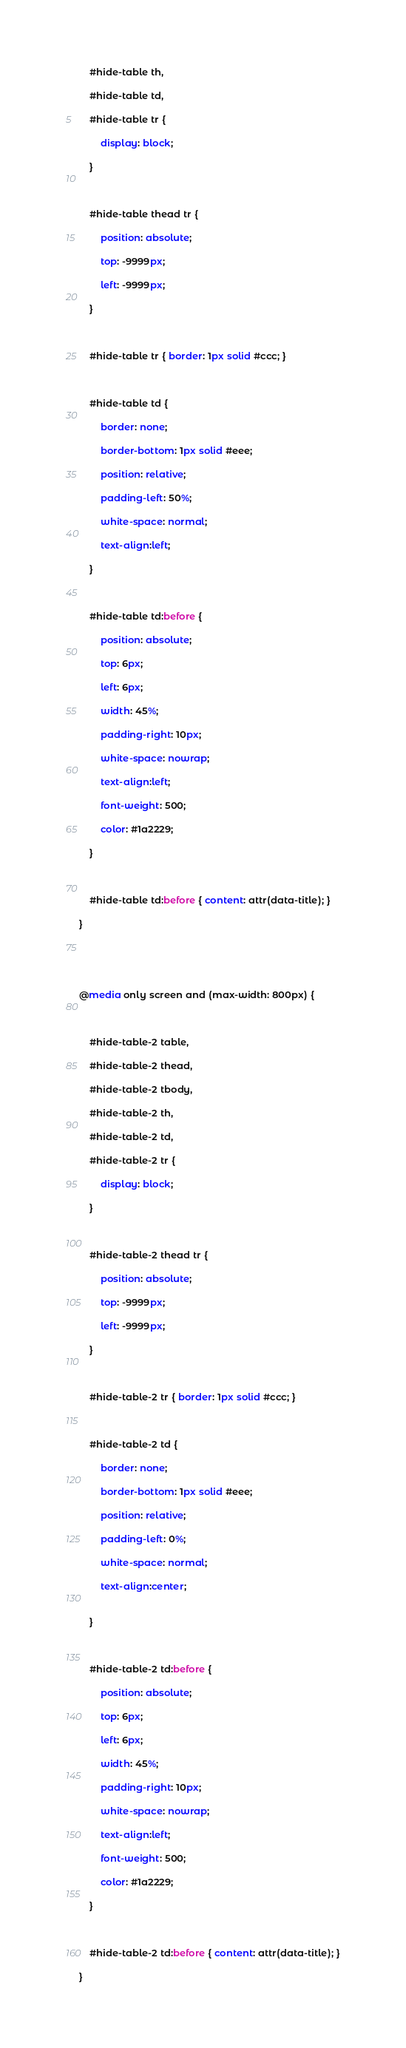Convert code to text. <code><loc_0><loc_0><loc_500><loc_500><_CSS_>    #hide-table th,

    #hide-table td,

    #hide-table tr {

        display: block;

    }



    #hide-table thead tr {

        position: absolute;

        top: -9999px;

        left: -9999px;

    }



    #hide-table tr { border: 1px solid #ccc; }



    #hide-table td {

        border: none;

        border-bottom: 1px solid #eee;

        position: relative;

        padding-left: 50%;

        white-space: normal;

        text-align:left;

    }



    #hide-table td:before {

        position: absolute;

        top: 6px;

        left: 6px;

        width: 45%;

        padding-right: 10px;

        white-space: nowrap;

        text-align:left;

        font-weight: 500;

        color: #1a2229;

    }



    #hide-table td:before { content: attr(data-title); }

}





@media only screen and (max-width: 800px) {



    #hide-table-2 table,

    #hide-table-2 thead,

    #hide-table-2 tbody,

    #hide-table-2 th,

    #hide-table-2 td,

    #hide-table-2 tr {

        display: block;

    }



    #hide-table-2 thead tr {

        position: absolute;

        top: -9999px;

        left: -9999px;

    }



    #hide-table-2 tr { border: 1px solid #ccc; }



    #hide-table-2 td {

        border: none;

        border-bottom: 1px solid #eee;

        position: relative;

        padding-left: 0%;

        white-space: normal;

        text-align:center;


    }



    #hide-table-2 td:before {

        position: absolute;

        top: 6px;

        left: 6px;

        width: 45%;

        padding-right: 10px;

        white-space: nowrap;

        text-align:left;

        font-weight: 500;

        color: #1a2229;

    }



    #hide-table-2 td:before { content: attr(data-title); }

}</code> 